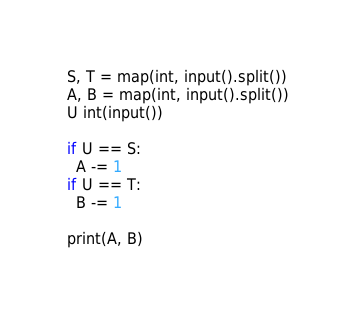<code> <loc_0><loc_0><loc_500><loc_500><_Python_>S, T = map(int, input().split())
A, B = map(int, input().split())
U int(input())

if U == S:
  A -= 1
if U == T:
  B -= 1
  
print(A, B)
</code> 